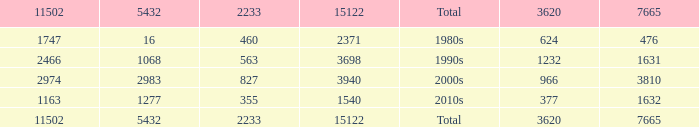What is the average 5432 value with a 11502 larger than 1163, a 15122 less than 15122, and a 3620 less than 624? None. Can you parse all the data within this table? {'header': ['11502', '5432', '2233', '15122', 'Total', '3620', '7665'], 'rows': [['1747', '16', '460', '2371', '1980s', '624', '476'], ['2466', '1068', '563', '3698', '1990s', '1232', '1631'], ['2974', '2983', '827', '3940', '2000s', '966', '3810'], ['1163', '1277', '355', '1540', '2010s', '377', '1632'], ['11502', '5432', '2233', '15122', 'Total', '3620', '7665']]} 